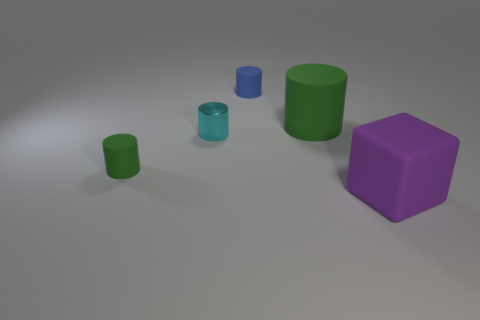Subtract all cyan cylinders. How many cylinders are left? 3 Subtract all blue cubes. How many green cylinders are left? 2 Add 2 large green cylinders. How many objects exist? 7 Subtract all cyan cylinders. How many cylinders are left? 3 Subtract all cylinders. How many objects are left? 1 Subtract all red cylinders. Subtract all cyan cubes. How many cylinders are left? 4 Add 3 tiny green rubber things. How many tiny green rubber things exist? 4 Subtract 1 purple blocks. How many objects are left? 4 Subtract all matte cubes. Subtract all cylinders. How many objects are left? 0 Add 5 rubber objects. How many rubber objects are left? 9 